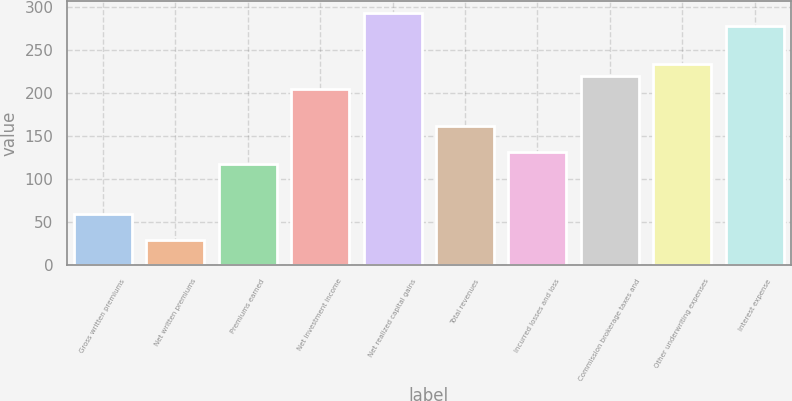Convert chart to OTSL. <chart><loc_0><loc_0><loc_500><loc_500><bar_chart><fcel>Gross written premiums<fcel>Net written premiums<fcel>Premiums earned<fcel>Net investment income<fcel>Net realized capital gains<fcel>Total revenues<fcel>Incurred losses and loss<fcel>Commission brokerage taxes and<fcel>Other underwriting expenses<fcel>Interest expense<nl><fcel>58.56<fcel>29.38<fcel>116.92<fcel>204.46<fcel>292<fcel>160.69<fcel>131.51<fcel>219.05<fcel>233.64<fcel>277.41<nl></chart> 